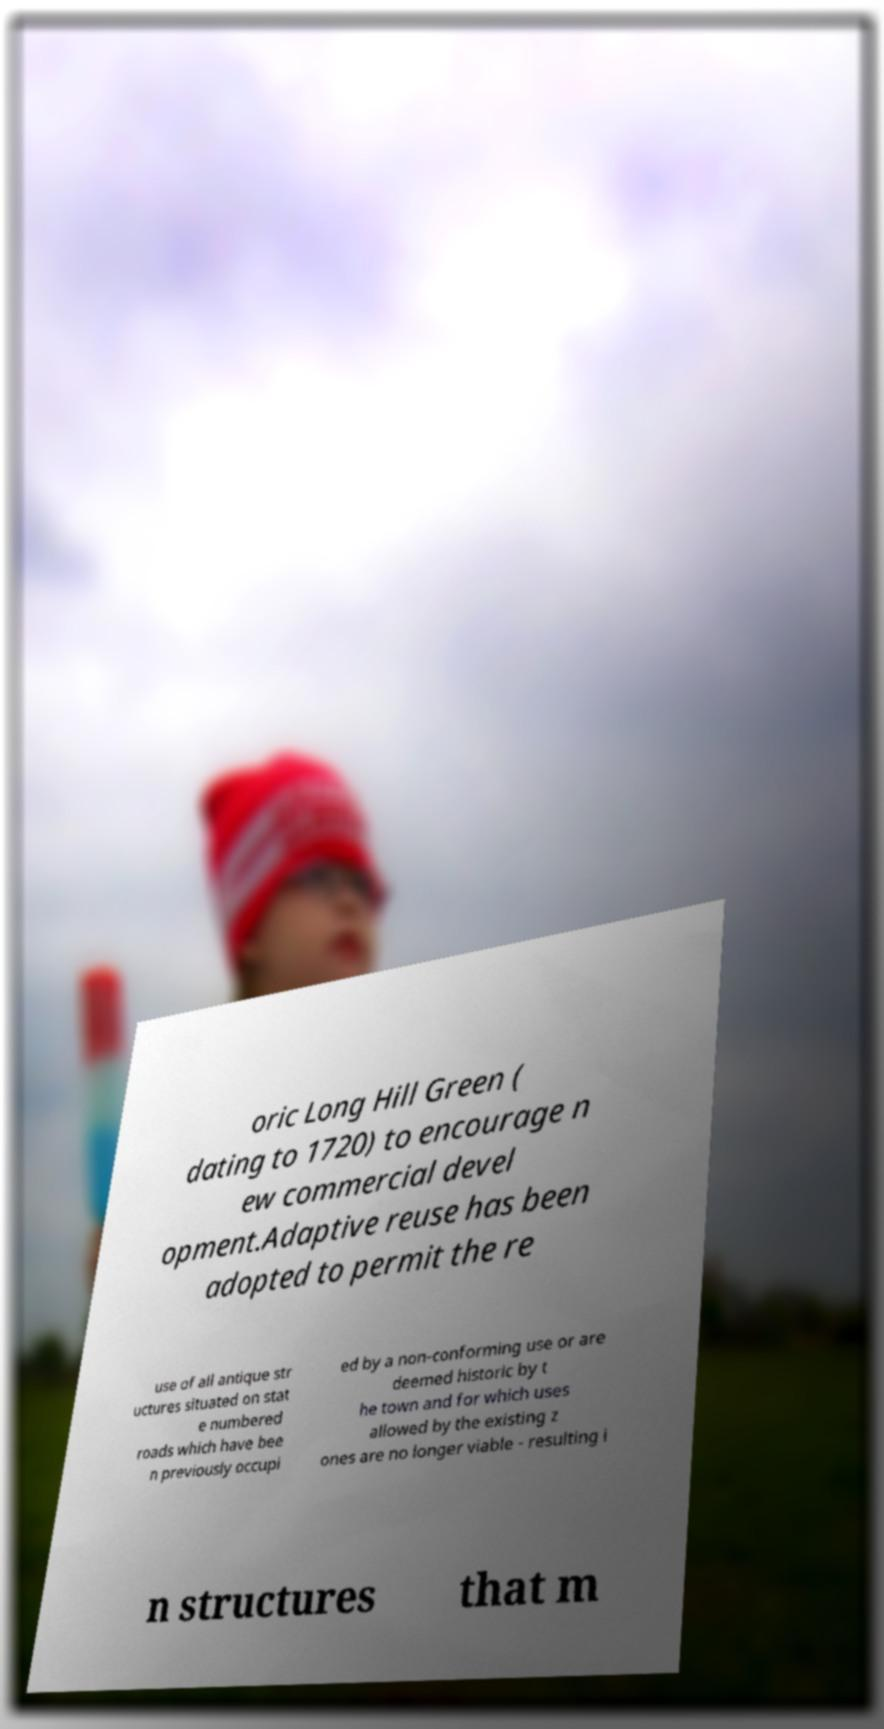Can you accurately transcribe the text from the provided image for me? oric Long Hill Green ( dating to 1720) to encourage n ew commercial devel opment.Adaptive reuse has been adopted to permit the re use of all antique str uctures situated on stat e numbered roads which have bee n previously occupi ed by a non-conforming use or are deemed historic by t he town and for which uses allowed by the existing z ones are no longer viable - resulting i n structures that m 